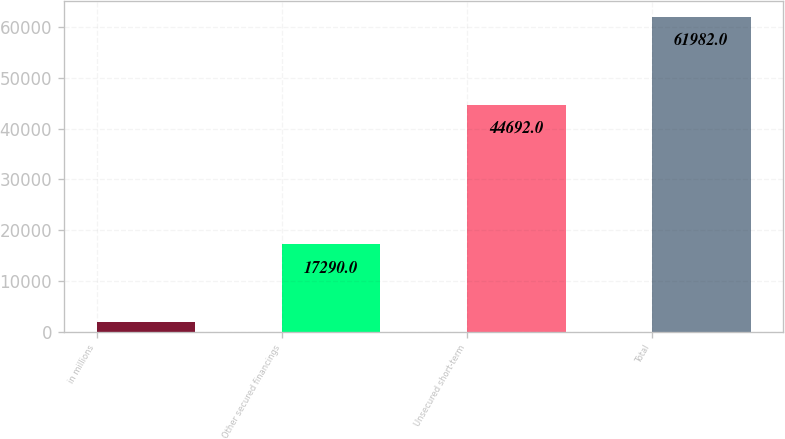<chart> <loc_0><loc_0><loc_500><loc_500><bar_chart><fcel>in millions<fcel>Other secured financings<fcel>Unsecured short-term<fcel>Total<nl><fcel>2013<fcel>17290<fcel>44692<fcel>61982<nl></chart> 